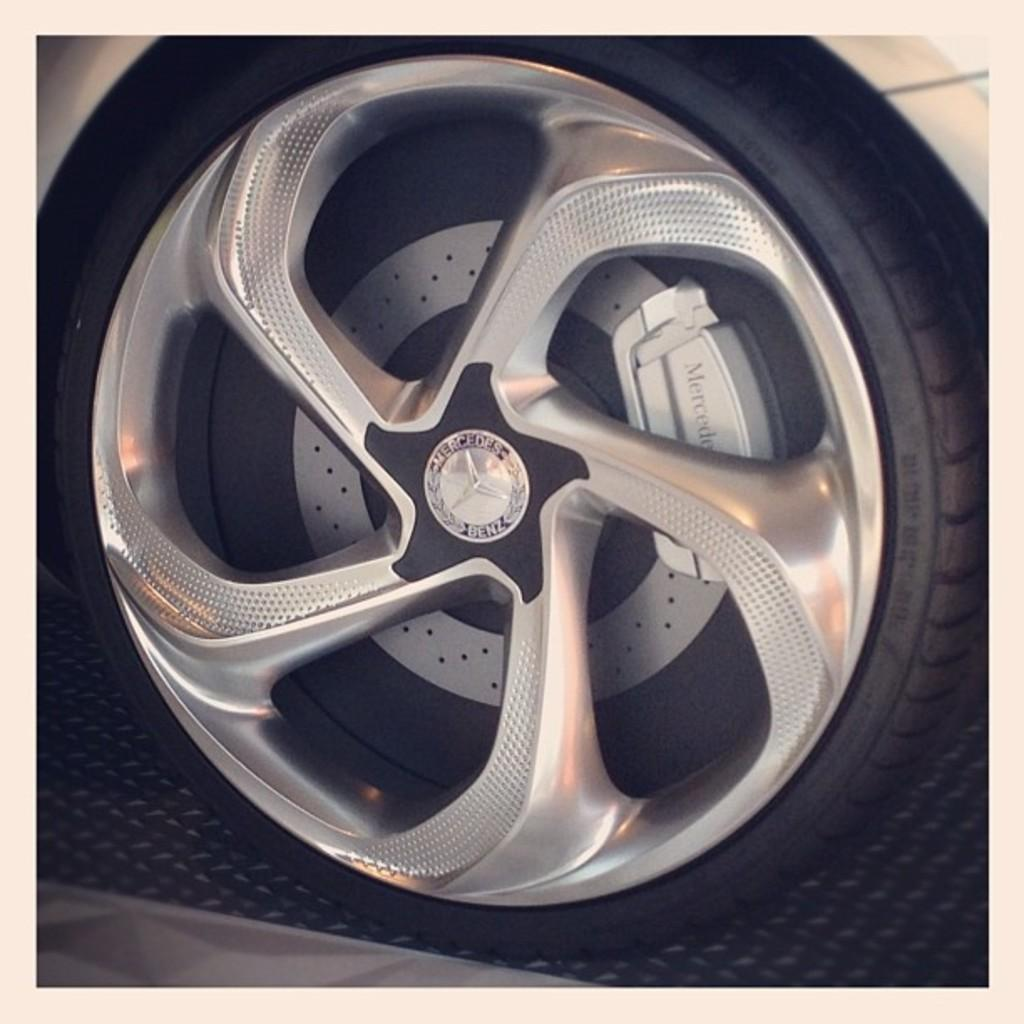What type of image is being described? The image is an edited picture. What can be seen in the image besides the editing? There is a vehicle in the image. Are there any unique features on the vehicle? Yes, there is text on the wheel of the vehicle. What type of insect is crawling on the governor's desk in the image? There is no insect or governor's desk present in the image; it features an edited picture of a vehicle with text on the wheel. 